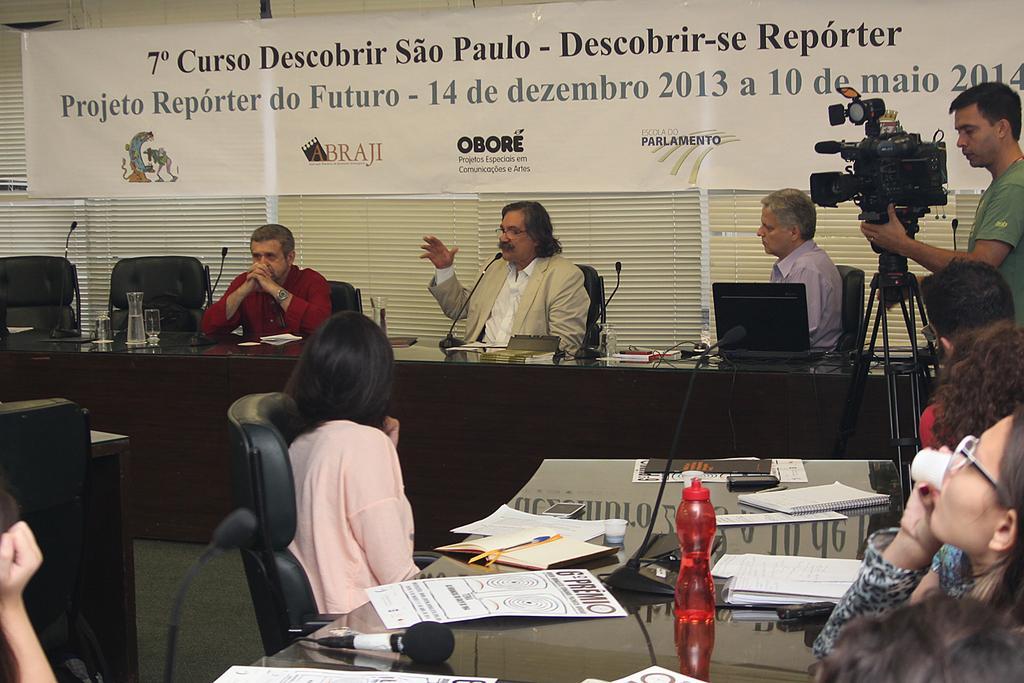Please provide a concise description of this image. In the center of the image we can see persons sitting at the table. On the table we can see mics, glass tumblers, laptops. At the bottom of the image we can see persons, chairs, table, water bottle, books and mic. In the background we can see cameraman, curtains, windows and banner. 